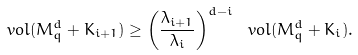Convert formula to latex. <formula><loc_0><loc_0><loc_500><loc_500>\ v o l ( M _ { q } ^ { d } + K _ { i + 1 } ) \geq \left ( \frac { \lambda _ { i + 1 } } { \lambda _ { i } } \right ) ^ { d - i } \ v o l ( M _ { q } ^ { d } + K _ { i } ) .</formula> 